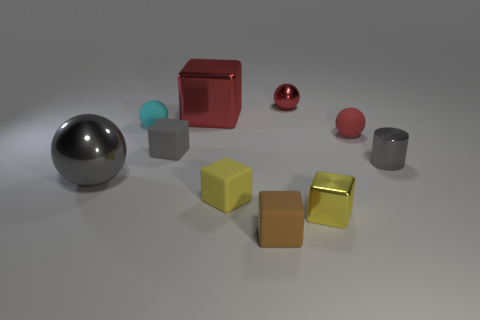Subtract all tiny metal cubes. How many cubes are left? 4 Subtract all cyan spheres. How many spheres are left? 3 Subtract all spheres. How many objects are left? 6 Subtract 4 blocks. How many blocks are left? 1 Subtract all blue cubes. Subtract all purple cylinders. How many cubes are left? 5 Subtract all red blocks. How many cyan spheres are left? 1 Subtract all small rubber cylinders. Subtract all small red rubber balls. How many objects are left? 9 Add 5 small gray cubes. How many small gray cubes are left? 6 Add 5 small cyan cylinders. How many small cyan cylinders exist? 5 Subtract 0 purple spheres. How many objects are left? 10 